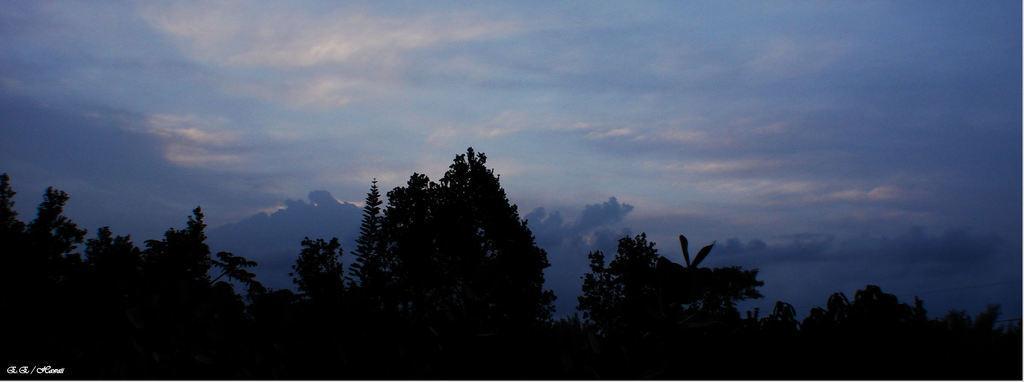How would you summarize this image in a sentence or two? In the image we can see sky on the top and trees. 